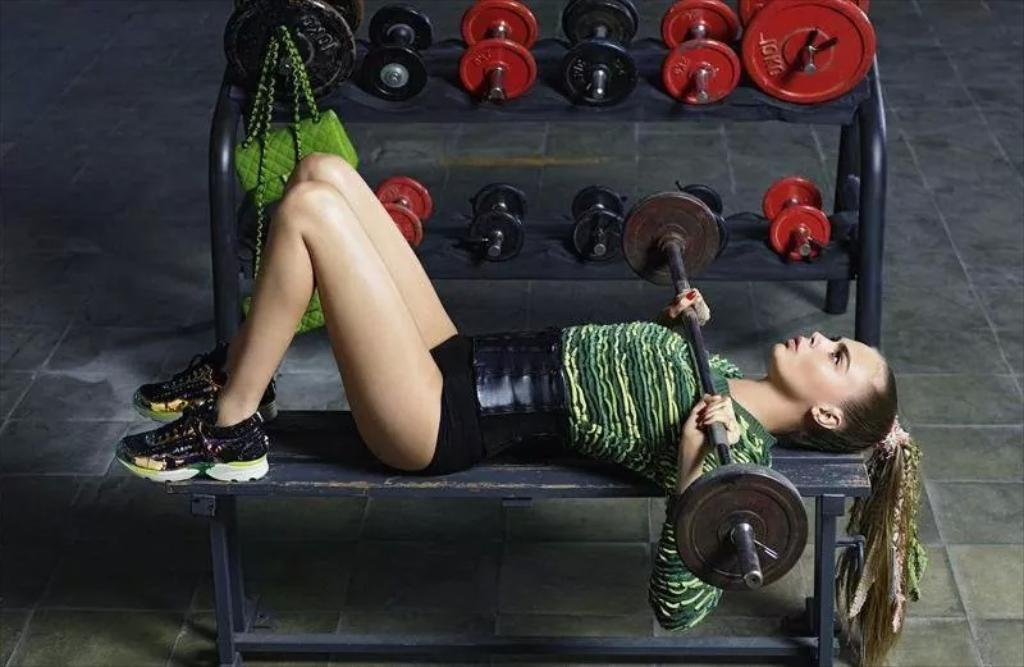Who is the main subject in the image? There is a lady in the image. What is the lady doing in the image? The lady is lying on a bench and holding a weight lifting rod. What other exercise equipment can be seen in the image? There are dumbbells on a stand in the image. Are there any personal belongings visible in the image? Yes, there are handbags in the image. What day of the week is it in the image? The day of the week is not mentioned or visible in the image. Who is the porter in the image? There is no porter present in the image. 